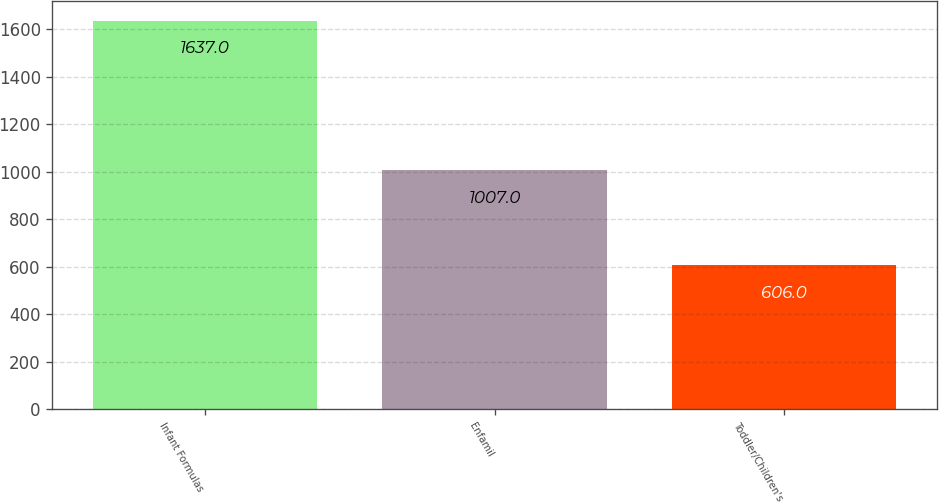Convert chart to OTSL. <chart><loc_0><loc_0><loc_500><loc_500><bar_chart><fcel>Infant Formulas<fcel>Enfamil<fcel>Toddler/Children's<nl><fcel>1637<fcel>1007<fcel>606<nl></chart> 